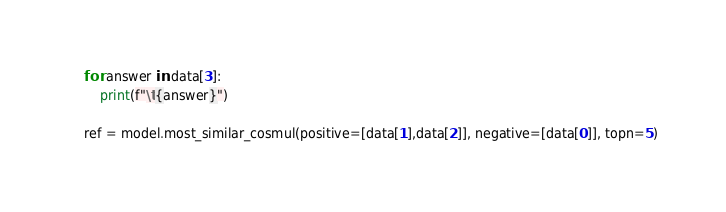<code> <loc_0><loc_0><loc_500><loc_500><_Python_>    for answer in data[3]:
        print(f"\t{answer}")

    ref = model.most_similar_cosmul(positive=[data[1],data[2]], negative=[data[0]], topn=5)</code> 